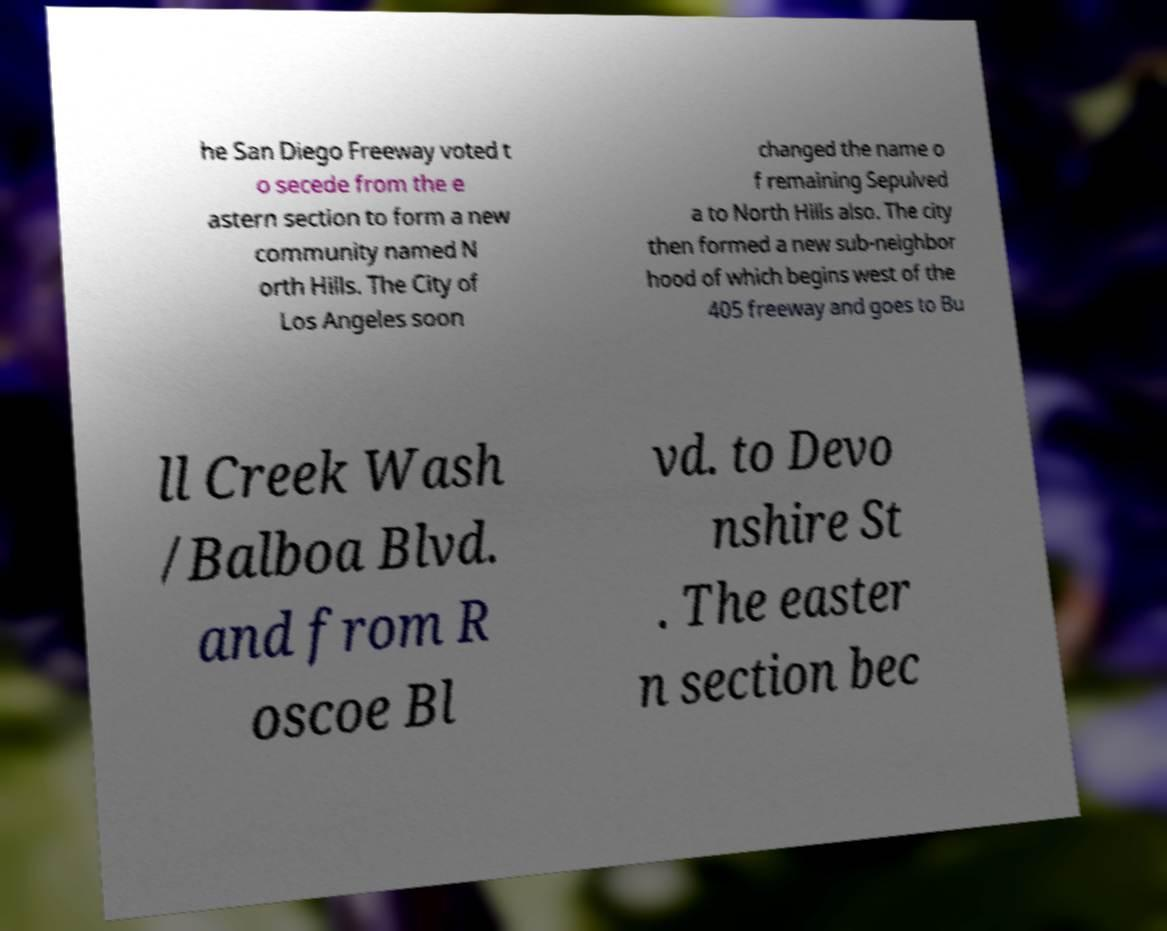Could you extract and type out the text from this image? he San Diego Freeway voted t o secede from the e astern section to form a new community named N orth Hills. The City of Los Angeles soon changed the name o f remaining Sepulved a to North Hills also. The city then formed a new sub-neighbor hood of which begins west of the 405 freeway and goes to Bu ll Creek Wash /Balboa Blvd. and from R oscoe Bl vd. to Devo nshire St . The easter n section bec 